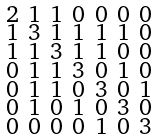Convert formula to latex. <formula><loc_0><loc_0><loc_500><loc_500>\begin{smallmatrix} 2 & 1 & 1 & 0 & 0 & 0 & 0 \\ 1 & 3 & 1 & 1 & 1 & 1 & 0 \\ 1 & 1 & 3 & 1 & 1 & 0 & 0 \\ 0 & 1 & 1 & 3 & 0 & 1 & 0 \\ 0 & 1 & 1 & 0 & 3 & 0 & 1 \\ 0 & 1 & 0 & 1 & 0 & 3 & 0 \\ 0 & 0 & 0 & 0 & 1 & 0 & 3 \end{smallmatrix}</formula> 